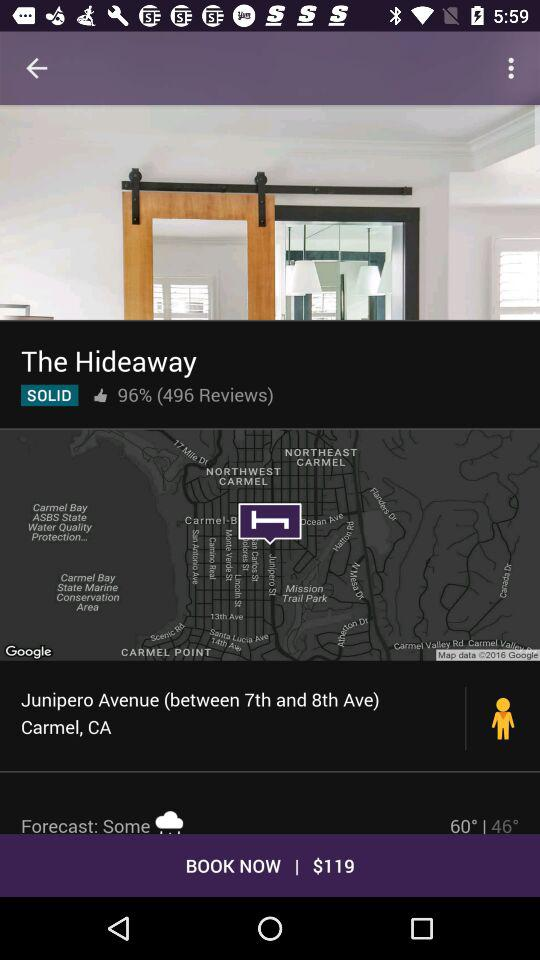What is the percentage of likes? The percentage of likes is 96. 